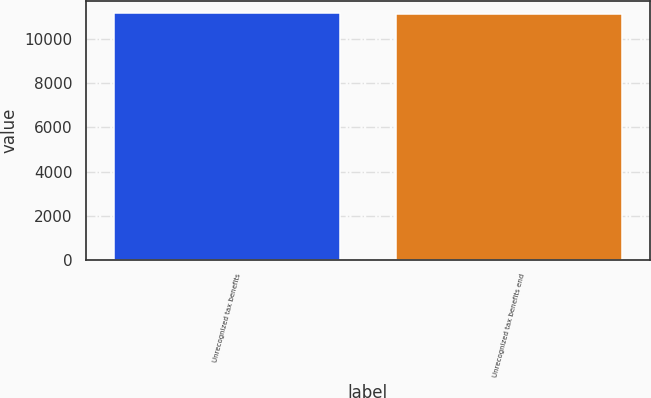Convert chart. <chart><loc_0><loc_0><loc_500><loc_500><bar_chart><fcel>Unrecognized tax benefits<fcel>Unrecognized tax benefits end<nl><fcel>11174<fcel>11144<nl></chart> 